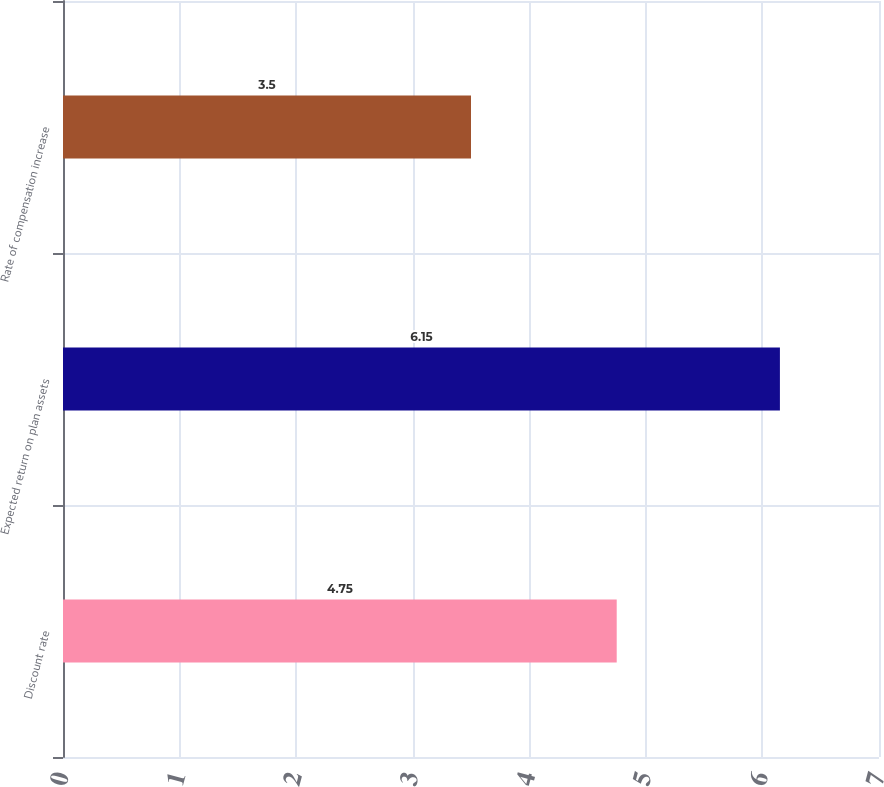Convert chart. <chart><loc_0><loc_0><loc_500><loc_500><bar_chart><fcel>Discount rate<fcel>Expected return on plan assets<fcel>Rate of compensation increase<nl><fcel>4.75<fcel>6.15<fcel>3.5<nl></chart> 